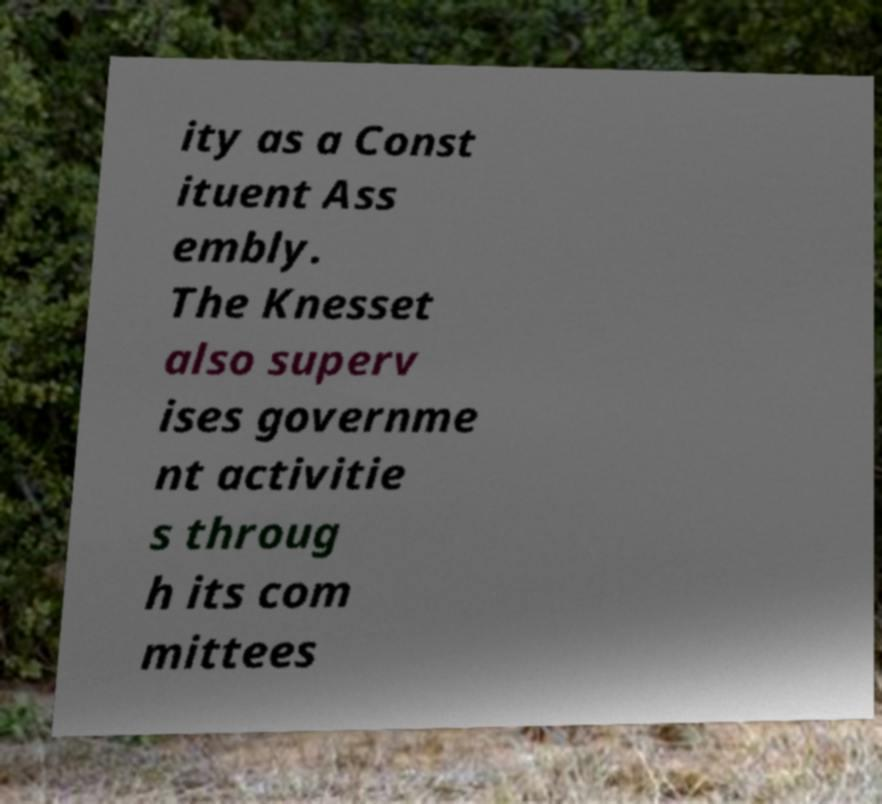Please identify and transcribe the text found in this image. ity as a Const ituent Ass embly. The Knesset also superv ises governme nt activitie s throug h its com mittees 